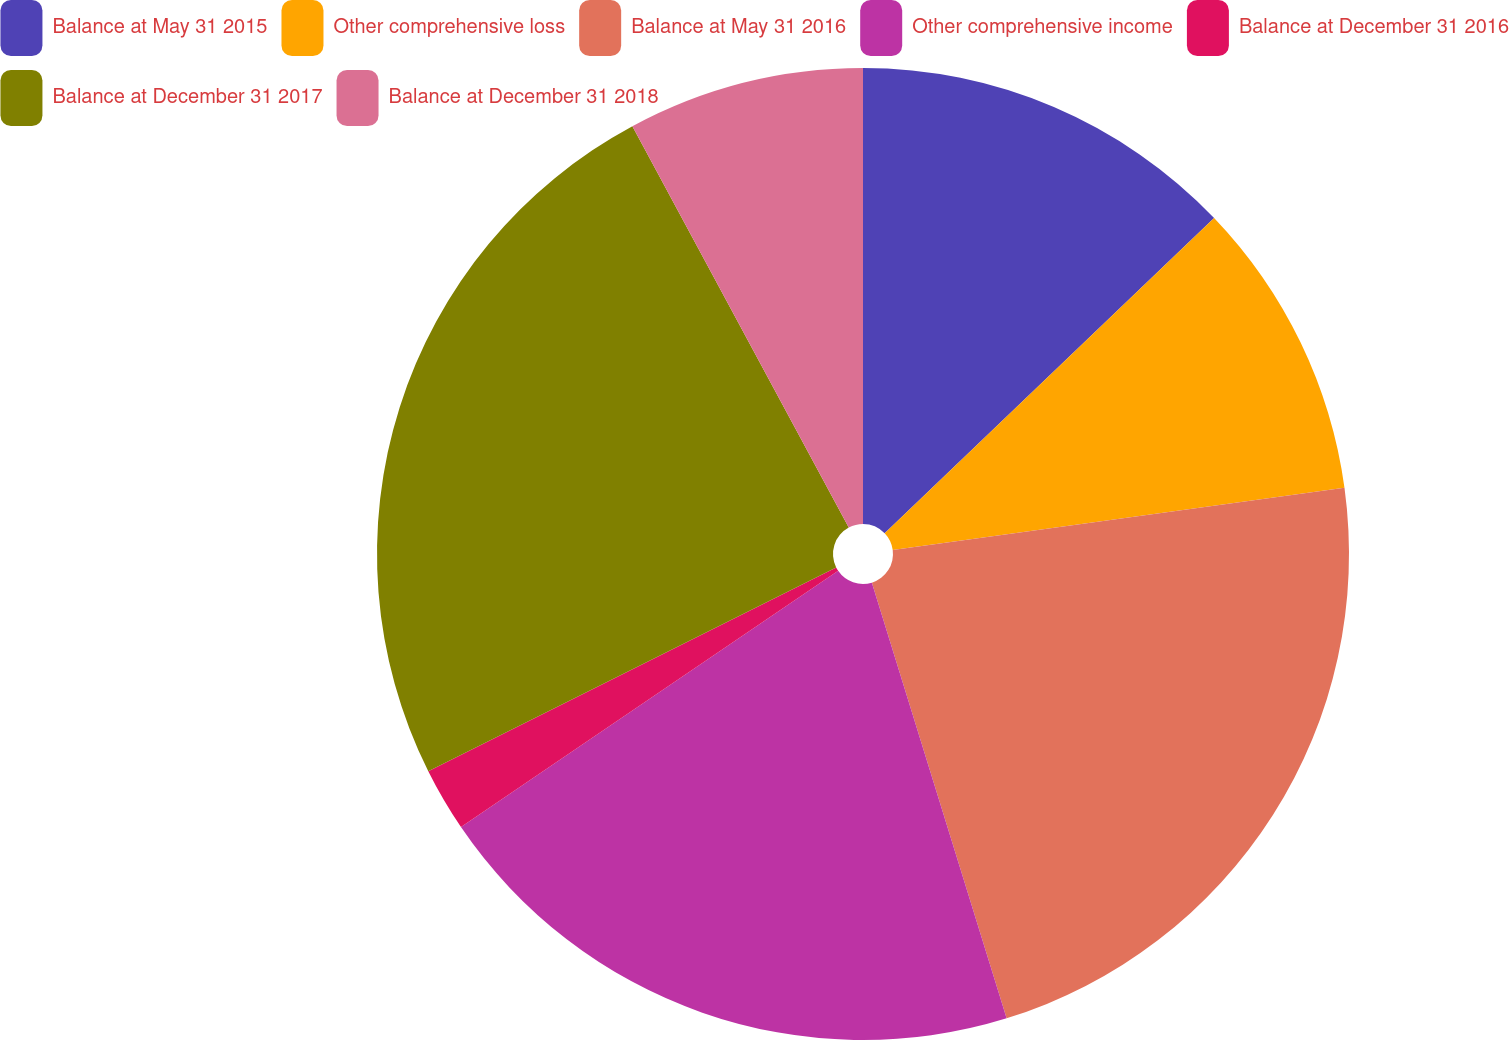<chart> <loc_0><loc_0><loc_500><loc_500><pie_chart><fcel>Balance at May 31 2015<fcel>Other comprehensive loss<fcel>Balance at May 31 2016<fcel>Other comprehensive income<fcel>Balance at December 31 2016<fcel>Balance at December 31 2017<fcel>Balance at December 31 2018<nl><fcel>12.85%<fcel>9.98%<fcel>22.4%<fcel>20.28%<fcel>2.12%<fcel>24.51%<fcel>7.87%<nl></chart> 